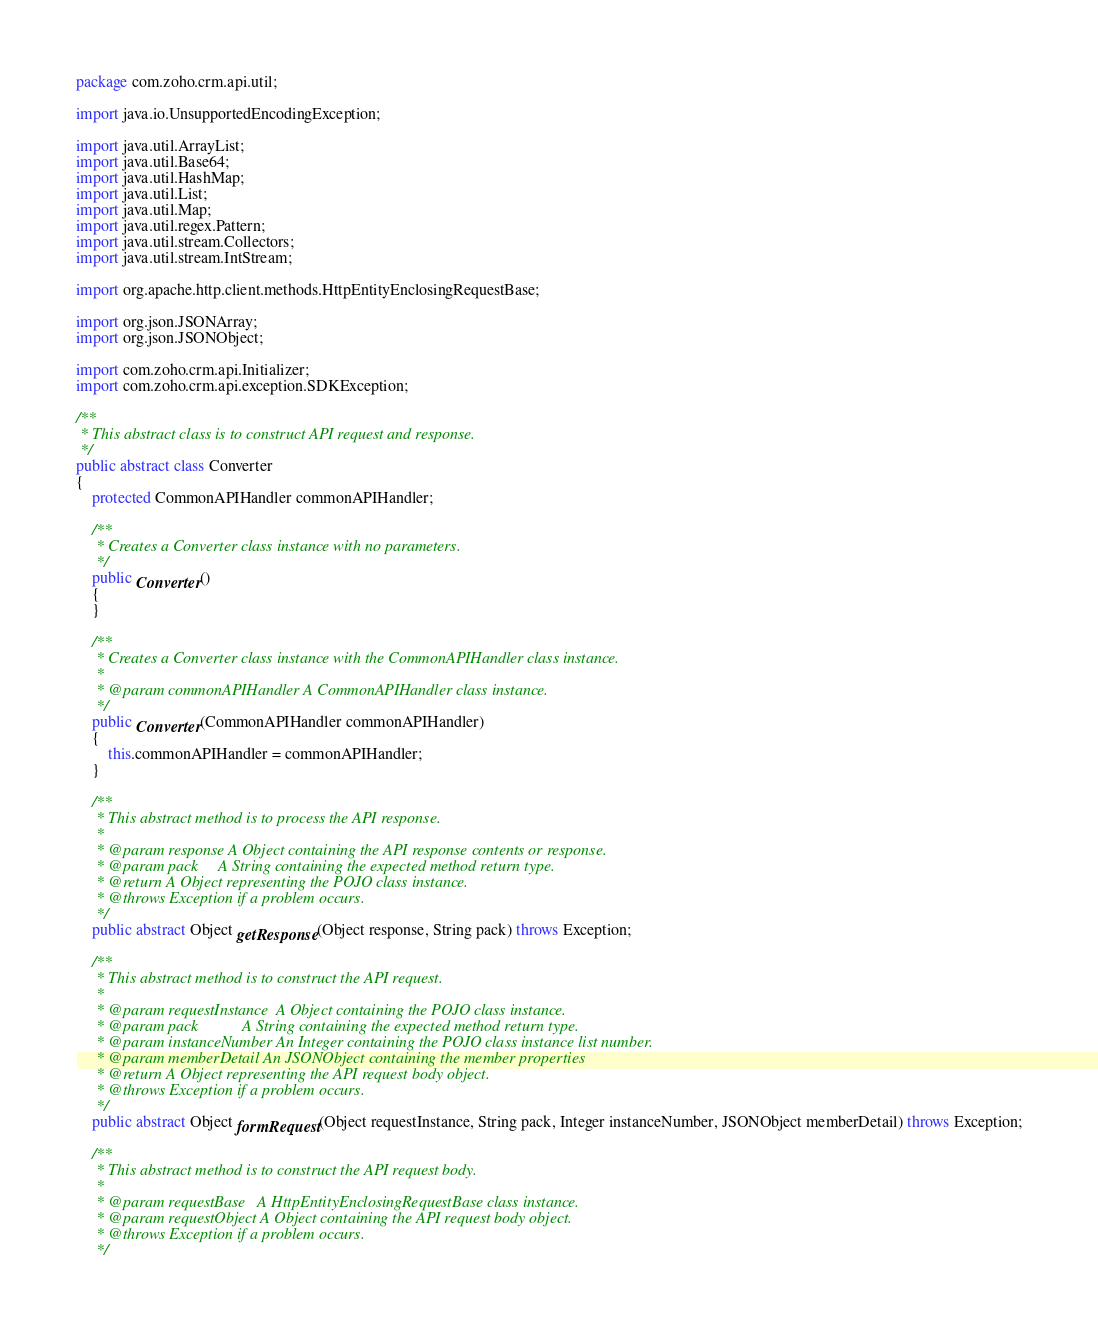<code> <loc_0><loc_0><loc_500><loc_500><_Java_>package com.zoho.crm.api.util;

import java.io.UnsupportedEncodingException;

import java.util.ArrayList;
import java.util.Base64;
import java.util.HashMap;
import java.util.List;
import java.util.Map;
import java.util.regex.Pattern;
import java.util.stream.Collectors;
import java.util.stream.IntStream;

import org.apache.http.client.methods.HttpEntityEnclosingRequestBase;

import org.json.JSONArray;
import org.json.JSONObject;

import com.zoho.crm.api.Initializer;
import com.zoho.crm.api.exception.SDKException;

/**
 * This abstract class is to construct API request and response.
 */
public abstract class Converter
{
	protected CommonAPIHandler commonAPIHandler;

	/**
	 * Creates a Converter class instance with no parameters.
	 */
	public Converter()
	{
	}

	/**
	 * Creates a Converter class instance with the CommonAPIHandler class instance.
	 * 
	 * @param commonAPIHandler A CommonAPIHandler class instance.
	 */
	public Converter(CommonAPIHandler commonAPIHandler)
	{
		this.commonAPIHandler = commonAPIHandler;
	}

	/**
	 * This abstract method is to process the API response.
	 * 
	 * @param response A Object containing the API response contents or response.
	 * @param pack     A String containing the expected method return type.
	 * @return A Object representing the POJO class instance.
	 * @throws Exception if a problem occurs.
	 */
	public abstract Object getResponse(Object response, String pack) throws Exception;

	/**
	 * This abstract method is to construct the API request.
	 * 
	 * @param requestInstance  A Object containing the POJO class instance.
	 * @param pack           A String containing the expected method return type.
	 * @param instanceNumber An Integer containing the POJO class instance list number.
	 * @param memberDetail An JSONObject containing the member properties
	 * @return A Object representing the API request body object.
	 * @throws Exception if a problem occurs.
	 */
	public abstract Object formRequest(Object requestInstance, String pack, Integer instanceNumber, JSONObject memberDetail) throws Exception;

	/**
	 * This abstract method is to construct the API request body.
	 * 
	 * @param requestBase   A HttpEntityEnclosingRequestBase class instance.
	 * @param requestObject A Object containing the API request body object.
	 * @throws Exception if a problem occurs.
	 */</code> 